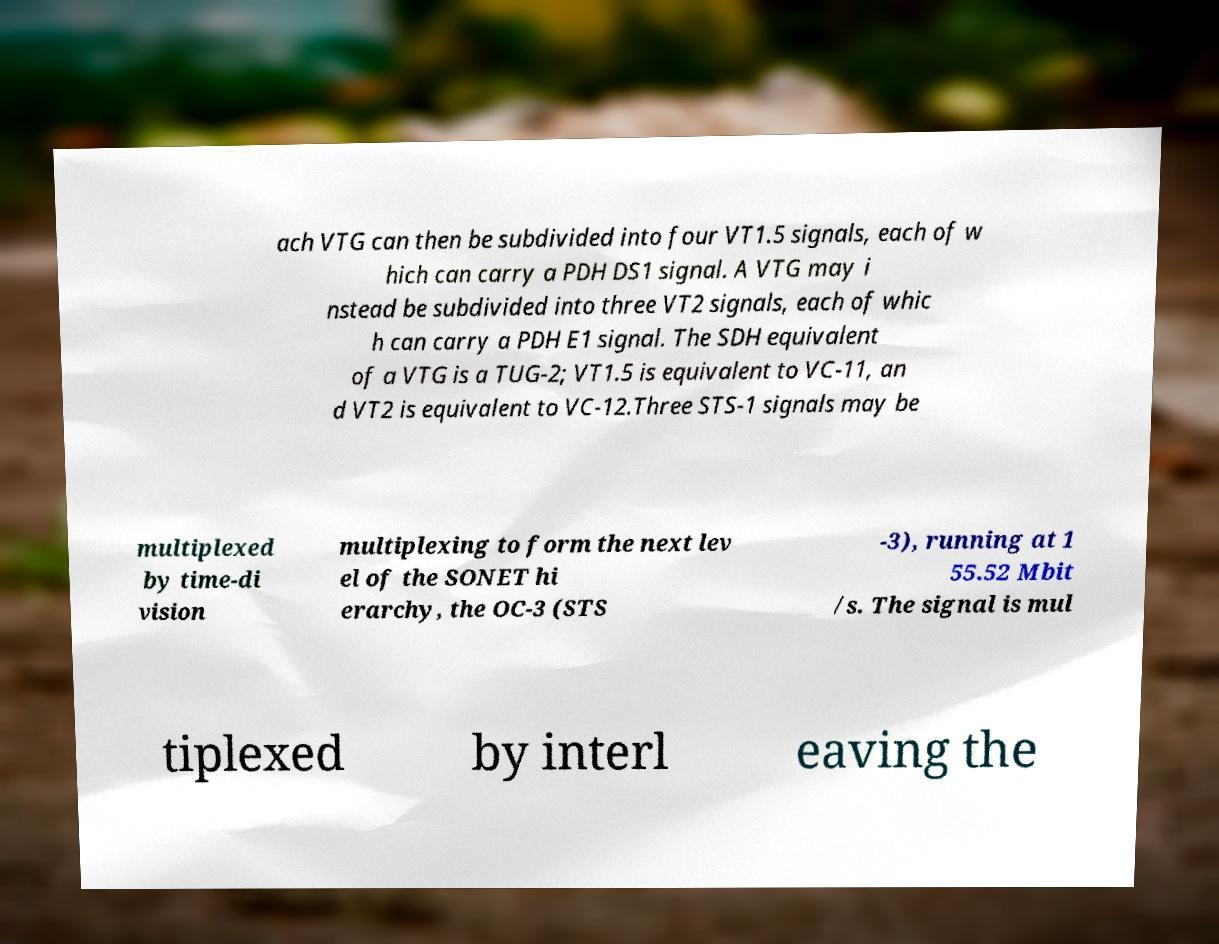There's text embedded in this image that I need extracted. Can you transcribe it verbatim? ach VTG can then be subdivided into four VT1.5 signals, each of w hich can carry a PDH DS1 signal. A VTG may i nstead be subdivided into three VT2 signals, each of whic h can carry a PDH E1 signal. The SDH equivalent of a VTG is a TUG-2; VT1.5 is equivalent to VC-11, an d VT2 is equivalent to VC-12.Three STS-1 signals may be multiplexed by time-di vision multiplexing to form the next lev el of the SONET hi erarchy, the OC-3 (STS -3), running at 1 55.52 Mbit /s. The signal is mul tiplexed by interl eaving the 